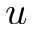<formula> <loc_0><loc_0><loc_500><loc_500>u</formula> 